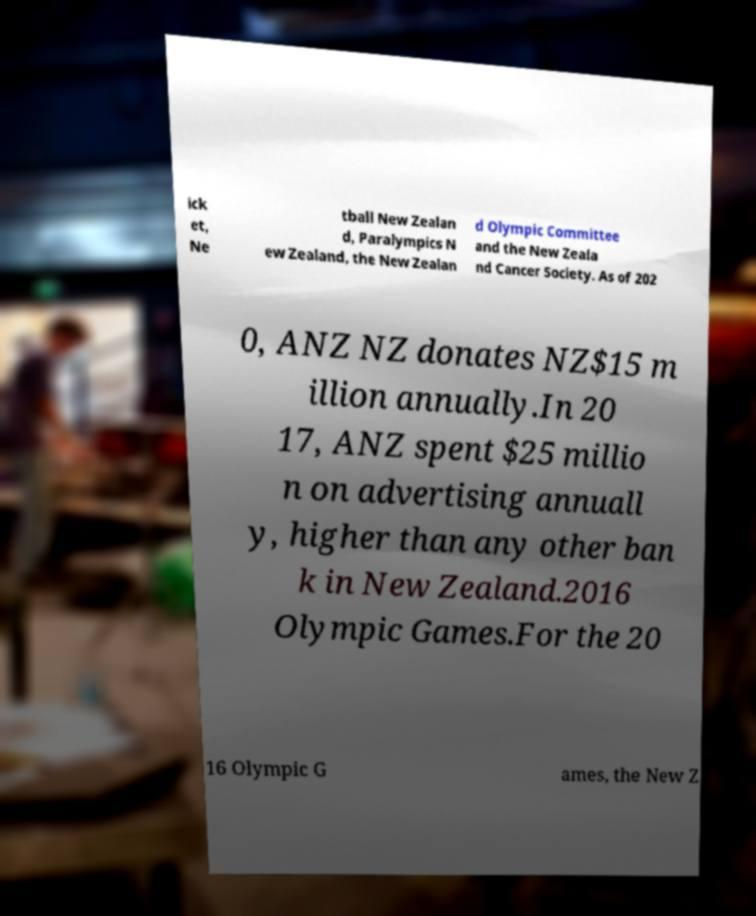Can you read and provide the text displayed in the image?This photo seems to have some interesting text. Can you extract and type it out for me? ick et, Ne tball New Zealan d, Paralympics N ew Zealand, the New Zealan d Olympic Committee and the New Zeala nd Cancer Society. As of 202 0, ANZ NZ donates NZ$15 m illion annually.In 20 17, ANZ spent $25 millio n on advertising annuall y, higher than any other ban k in New Zealand.2016 Olympic Games.For the 20 16 Olympic G ames, the New Z 